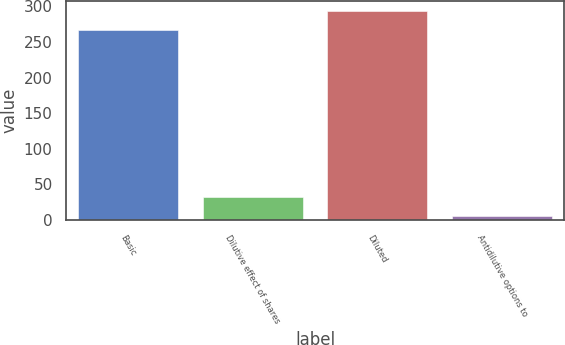<chart> <loc_0><loc_0><loc_500><loc_500><bar_chart><fcel>Basic<fcel>Dilutive effect of shares<fcel>Diluted<fcel>Antidilutive options to<nl><fcel>266.4<fcel>32.26<fcel>293.06<fcel>5.6<nl></chart> 